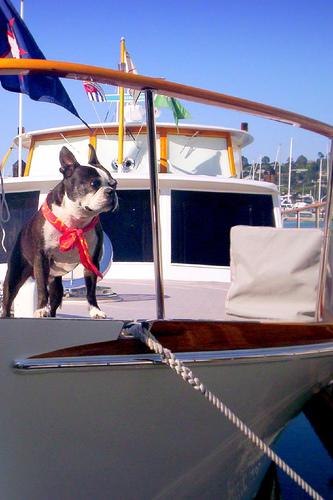What color is the dog's bandana?
Answer briefly. Red. Is the dog happy?
Give a very brief answer. Yes. Is this dog waiting for someone?
Concise answer only. Yes. 